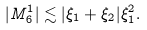<formula> <loc_0><loc_0><loc_500><loc_500>| M _ { 6 } ^ { 1 } | \lesssim | \xi _ { 1 } + \xi _ { 2 } | \xi _ { 1 } ^ { 2 } .</formula> 